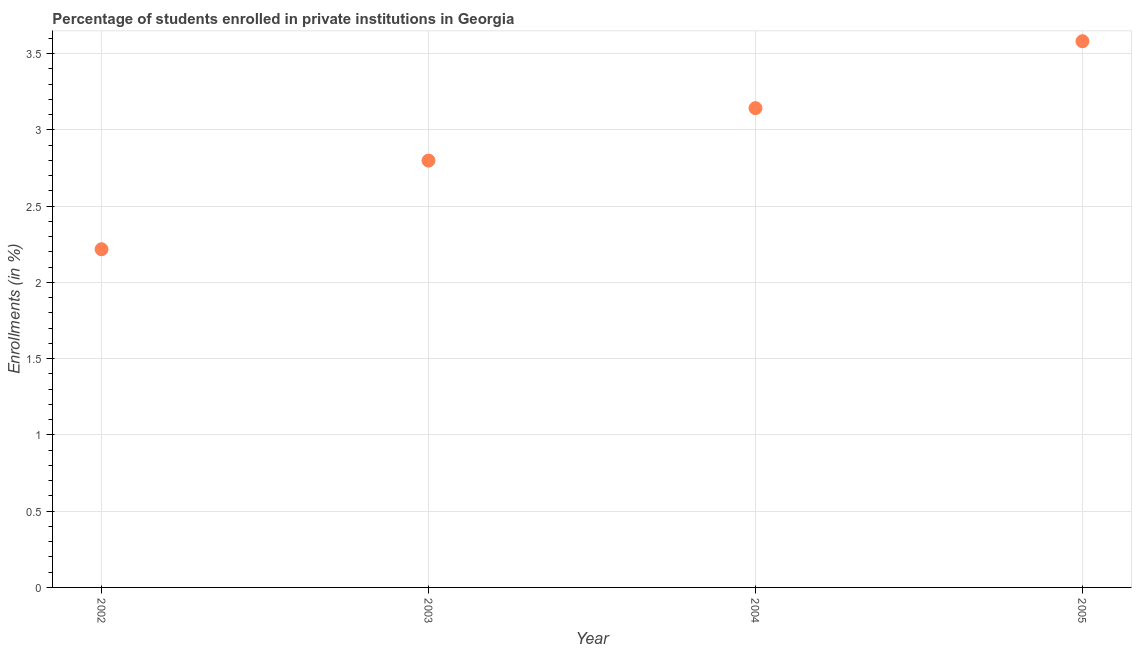What is the enrollments in private institutions in 2004?
Keep it short and to the point. 3.14. Across all years, what is the maximum enrollments in private institutions?
Offer a very short reply. 3.58. Across all years, what is the minimum enrollments in private institutions?
Offer a very short reply. 2.22. In which year was the enrollments in private institutions minimum?
Offer a terse response. 2002. What is the sum of the enrollments in private institutions?
Provide a succinct answer. 11.74. What is the difference between the enrollments in private institutions in 2002 and 2003?
Offer a very short reply. -0.58. What is the average enrollments in private institutions per year?
Offer a terse response. 2.93. What is the median enrollments in private institutions?
Offer a terse response. 2.97. What is the ratio of the enrollments in private institutions in 2003 to that in 2004?
Keep it short and to the point. 0.89. What is the difference between the highest and the second highest enrollments in private institutions?
Offer a terse response. 0.44. Is the sum of the enrollments in private institutions in 2002 and 2003 greater than the maximum enrollments in private institutions across all years?
Offer a very short reply. Yes. What is the difference between the highest and the lowest enrollments in private institutions?
Make the answer very short. 1.36. How many dotlines are there?
Ensure brevity in your answer.  1. Are the values on the major ticks of Y-axis written in scientific E-notation?
Your answer should be very brief. No. Does the graph contain grids?
Your response must be concise. Yes. What is the title of the graph?
Your response must be concise. Percentage of students enrolled in private institutions in Georgia. What is the label or title of the Y-axis?
Provide a short and direct response. Enrollments (in %). What is the Enrollments (in %) in 2002?
Provide a short and direct response. 2.22. What is the Enrollments (in %) in 2003?
Provide a short and direct response. 2.8. What is the Enrollments (in %) in 2004?
Your answer should be compact. 3.14. What is the Enrollments (in %) in 2005?
Your answer should be compact. 3.58. What is the difference between the Enrollments (in %) in 2002 and 2003?
Ensure brevity in your answer.  -0.58. What is the difference between the Enrollments (in %) in 2002 and 2004?
Your answer should be very brief. -0.92. What is the difference between the Enrollments (in %) in 2002 and 2005?
Make the answer very short. -1.36. What is the difference between the Enrollments (in %) in 2003 and 2004?
Your answer should be very brief. -0.34. What is the difference between the Enrollments (in %) in 2003 and 2005?
Your answer should be compact. -0.78. What is the difference between the Enrollments (in %) in 2004 and 2005?
Keep it short and to the point. -0.44. What is the ratio of the Enrollments (in %) in 2002 to that in 2003?
Ensure brevity in your answer.  0.79. What is the ratio of the Enrollments (in %) in 2002 to that in 2004?
Your answer should be very brief. 0.71. What is the ratio of the Enrollments (in %) in 2002 to that in 2005?
Offer a terse response. 0.62. What is the ratio of the Enrollments (in %) in 2003 to that in 2004?
Make the answer very short. 0.89. What is the ratio of the Enrollments (in %) in 2003 to that in 2005?
Make the answer very short. 0.78. What is the ratio of the Enrollments (in %) in 2004 to that in 2005?
Offer a very short reply. 0.88. 